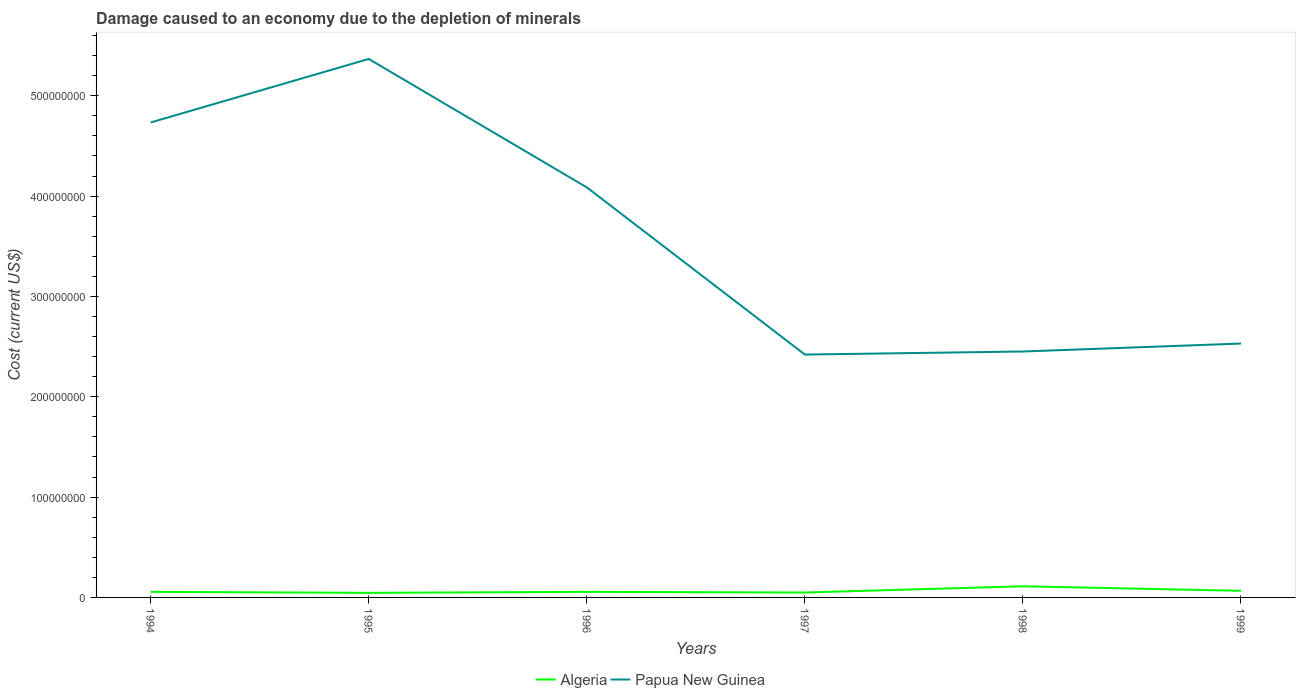Does the line corresponding to Papua New Guinea intersect with the line corresponding to Algeria?
Offer a terse response. No. Across all years, what is the maximum cost of damage caused due to the depletion of minerals in Algeria?
Offer a very short reply. 4.58e+06. In which year was the cost of damage caused due to the depletion of minerals in Algeria maximum?
Ensure brevity in your answer.  1995. What is the total cost of damage caused due to the depletion of minerals in Algeria in the graph?
Your response must be concise. -5.57e+06. What is the difference between the highest and the second highest cost of damage caused due to the depletion of minerals in Algeria?
Keep it short and to the point. 6.54e+06. Is the cost of damage caused due to the depletion of minerals in Algeria strictly greater than the cost of damage caused due to the depletion of minerals in Papua New Guinea over the years?
Give a very brief answer. Yes. How many years are there in the graph?
Your response must be concise. 6. Are the values on the major ticks of Y-axis written in scientific E-notation?
Make the answer very short. No. How are the legend labels stacked?
Keep it short and to the point. Horizontal. What is the title of the graph?
Ensure brevity in your answer.  Damage caused to an economy due to the depletion of minerals. What is the label or title of the X-axis?
Offer a very short reply. Years. What is the label or title of the Y-axis?
Give a very brief answer. Cost (current US$). What is the Cost (current US$) in Algeria in 1994?
Ensure brevity in your answer.  5.54e+06. What is the Cost (current US$) of Papua New Guinea in 1994?
Your response must be concise. 4.73e+08. What is the Cost (current US$) in Algeria in 1995?
Offer a terse response. 4.58e+06. What is the Cost (current US$) in Papua New Guinea in 1995?
Your response must be concise. 5.37e+08. What is the Cost (current US$) of Algeria in 1996?
Provide a succinct answer. 5.55e+06. What is the Cost (current US$) of Papua New Guinea in 1996?
Make the answer very short. 4.09e+08. What is the Cost (current US$) in Algeria in 1997?
Provide a succinct answer. 4.89e+06. What is the Cost (current US$) in Papua New Guinea in 1997?
Provide a short and direct response. 2.42e+08. What is the Cost (current US$) in Algeria in 1998?
Offer a very short reply. 1.11e+07. What is the Cost (current US$) in Papua New Guinea in 1998?
Your answer should be very brief. 2.45e+08. What is the Cost (current US$) of Algeria in 1999?
Ensure brevity in your answer.  6.60e+06. What is the Cost (current US$) in Papua New Guinea in 1999?
Offer a very short reply. 2.53e+08. Across all years, what is the maximum Cost (current US$) in Algeria?
Your answer should be very brief. 1.11e+07. Across all years, what is the maximum Cost (current US$) of Papua New Guinea?
Provide a succinct answer. 5.37e+08. Across all years, what is the minimum Cost (current US$) of Algeria?
Make the answer very short. 4.58e+06. Across all years, what is the minimum Cost (current US$) of Papua New Guinea?
Your response must be concise. 2.42e+08. What is the total Cost (current US$) of Algeria in the graph?
Your response must be concise. 3.83e+07. What is the total Cost (current US$) in Papua New Guinea in the graph?
Your response must be concise. 2.16e+09. What is the difference between the Cost (current US$) of Algeria in 1994 and that in 1995?
Offer a very short reply. 9.70e+05. What is the difference between the Cost (current US$) in Papua New Guinea in 1994 and that in 1995?
Give a very brief answer. -6.33e+07. What is the difference between the Cost (current US$) of Algeria in 1994 and that in 1996?
Offer a very short reply. -5232.42. What is the difference between the Cost (current US$) in Papua New Guinea in 1994 and that in 1996?
Provide a succinct answer. 6.47e+07. What is the difference between the Cost (current US$) in Algeria in 1994 and that in 1997?
Make the answer very short. 6.50e+05. What is the difference between the Cost (current US$) in Papua New Guinea in 1994 and that in 1997?
Ensure brevity in your answer.  2.31e+08. What is the difference between the Cost (current US$) of Algeria in 1994 and that in 1998?
Your response must be concise. -5.57e+06. What is the difference between the Cost (current US$) of Papua New Guinea in 1994 and that in 1998?
Provide a short and direct response. 2.28e+08. What is the difference between the Cost (current US$) in Algeria in 1994 and that in 1999?
Give a very brief answer. -1.06e+06. What is the difference between the Cost (current US$) in Papua New Guinea in 1994 and that in 1999?
Offer a very short reply. 2.20e+08. What is the difference between the Cost (current US$) of Algeria in 1995 and that in 1996?
Offer a very short reply. -9.75e+05. What is the difference between the Cost (current US$) in Papua New Guinea in 1995 and that in 1996?
Your response must be concise. 1.28e+08. What is the difference between the Cost (current US$) of Algeria in 1995 and that in 1997?
Make the answer very short. -3.20e+05. What is the difference between the Cost (current US$) in Papua New Guinea in 1995 and that in 1997?
Provide a succinct answer. 2.95e+08. What is the difference between the Cost (current US$) in Algeria in 1995 and that in 1998?
Give a very brief answer. -6.54e+06. What is the difference between the Cost (current US$) of Papua New Guinea in 1995 and that in 1998?
Offer a very short reply. 2.92e+08. What is the difference between the Cost (current US$) in Algeria in 1995 and that in 1999?
Your answer should be very brief. -2.03e+06. What is the difference between the Cost (current US$) in Papua New Guinea in 1995 and that in 1999?
Offer a very short reply. 2.84e+08. What is the difference between the Cost (current US$) in Algeria in 1996 and that in 1997?
Your response must be concise. 6.55e+05. What is the difference between the Cost (current US$) in Papua New Guinea in 1996 and that in 1997?
Ensure brevity in your answer.  1.67e+08. What is the difference between the Cost (current US$) of Algeria in 1996 and that in 1998?
Give a very brief answer. -5.56e+06. What is the difference between the Cost (current US$) of Papua New Guinea in 1996 and that in 1998?
Your answer should be very brief. 1.64e+08. What is the difference between the Cost (current US$) of Algeria in 1996 and that in 1999?
Keep it short and to the point. -1.05e+06. What is the difference between the Cost (current US$) in Papua New Guinea in 1996 and that in 1999?
Ensure brevity in your answer.  1.56e+08. What is the difference between the Cost (current US$) of Algeria in 1997 and that in 1998?
Keep it short and to the point. -6.22e+06. What is the difference between the Cost (current US$) in Papua New Guinea in 1997 and that in 1998?
Ensure brevity in your answer.  -3.05e+06. What is the difference between the Cost (current US$) in Algeria in 1997 and that in 1999?
Offer a very short reply. -1.71e+06. What is the difference between the Cost (current US$) in Papua New Guinea in 1997 and that in 1999?
Provide a succinct answer. -1.10e+07. What is the difference between the Cost (current US$) in Algeria in 1998 and that in 1999?
Provide a short and direct response. 4.51e+06. What is the difference between the Cost (current US$) in Papua New Guinea in 1998 and that in 1999?
Give a very brief answer. -7.93e+06. What is the difference between the Cost (current US$) in Algeria in 1994 and the Cost (current US$) in Papua New Guinea in 1995?
Give a very brief answer. -5.31e+08. What is the difference between the Cost (current US$) of Algeria in 1994 and the Cost (current US$) of Papua New Guinea in 1996?
Your answer should be very brief. -4.03e+08. What is the difference between the Cost (current US$) of Algeria in 1994 and the Cost (current US$) of Papua New Guinea in 1997?
Give a very brief answer. -2.37e+08. What is the difference between the Cost (current US$) of Algeria in 1994 and the Cost (current US$) of Papua New Guinea in 1998?
Keep it short and to the point. -2.40e+08. What is the difference between the Cost (current US$) in Algeria in 1994 and the Cost (current US$) in Papua New Guinea in 1999?
Ensure brevity in your answer.  -2.47e+08. What is the difference between the Cost (current US$) of Algeria in 1995 and the Cost (current US$) of Papua New Guinea in 1996?
Keep it short and to the point. -4.04e+08. What is the difference between the Cost (current US$) in Algeria in 1995 and the Cost (current US$) in Papua New Guinea in 1997?
Make the answer very short. -2.37e+08. What is the difference between the Cost (current US$) in Algeria in 1995 and the Cost (current US$) in Papua New Guinea in 1998?
Ensure brevity in your answer.  -2.41e+08. What is the difference between the Cost (current US$) of Algeria in 1995 and the Cost (current US$) of Papua New Guinea in 1999?
Your answer should be compact. -2.48e+08. What is the difference between the Cost (current US$) of Algeria in 1996 and the Cost (current US$) of Papua New Guinea in 1997?
Offer a very short reply. -2.37e+08. What is the difference between the Cost (current US$) in Algeria in 1996 and the Cost (current US$) in Papua New Guinea in 1998?
Your response must be concise. -2.40e+08. What is the difference between the Cost (current US$) in Algeria in 1996 and the Cost (current US$) in Papua New Guinea in 1999?
Ensure brevity in your answer.  -2.47e+08. What is the difference between the Cost (current US$) of Algeria in 1997 and the Cost (current US$) of Papua New Guinea in 1998?
Your answer should be very brief. -2.40e+08. What is the difference between the Cost (current US$) in Algeria in 1997 and the Cost (current US$) in Papua New Guinea in 1999?
Give a very brief answer. -2.48e+08. What is the difference between the Cost (current US$) in Algeria in 1998 and the Cost (current US$) in Papua New Guinea in 1999?
Your response must be concise. -2.42e+08. What is the average Cost (current US$) in Algeria per year?
Your answer should be very brief. 6.38e+06. What is the average Cost (current US$) of Papua New Guinea per year?
Make the answer very short. 3.60e+08. In the year 1994, what is the difference between the Cost (current US$) in Algeria and Cost (current US$) in Papua New Guinea?
Ensure brevity in your answer.  -4.68e+08. In the year 1995, what is the difference between the Cost (current US$) in Algeria and Cost (current US$) in Papua New Guinea?
Provide a succinct answer. -5.32e+08. In the year 1996, what is the difference between the Cost (current US$) of Algeria and Cost (current US$) of Papua New Guinea?
Provide a succinct answer. -4.03e+08. In the year 1997, what is the difference between the Cost (current US$) in Algeria and Cost (current US$) in Papua New Guinea?
Keep it short and to the point. -2.37e+08. In the year 1998, what is the difference between the Cost (current US$) of Algeria and Cost (current US$) of Papua New Guinea?
Offer a very short reply. -2.34e+08. In the year 1999, what is the difference between the Cost (current US$) of Algeria and Cost (current US$) of Papua New Guinea?
Keep it short and to the point. -2.46e+08. What is the ratio of the Cost (current US$) in Algeria in 1994 to that in 1995?
Your answer should be compact. 1.21. What is the ratio of the Cost (current US$) of Papua New Guinea in 1994 to that in 1995?
Offer a very short reply. 0.88. What is the ratio of the Cost (current US$) in Papua New Guinea in 1994 to that in 1996?
Ensure brevity in your answer.  1.16. What is the ratio of the Cost (current US$) in Algeria in 1994 to that in 1997?
Give a very brief answer. 1.13. What is the ratio of the Cost (current US$) in Papua New Guinea in 1994 to that in 1997?
Your answer should be compact. 1.96. What is the ratio of the Cost (current US$) of Algeria in 1994 to that in 1998?
Ensure brevity in your answer.  0.5. What is the ratio of the Cost (current US$) in Papua New Guinea in 1994 to that in 1998?
Ensure brevity in your answer.  1.93. What is the ratio of the Cost (current US$) of Algeria in 1994 to that in 1999?
Offer a very short reply. 0.84. What is the ratio of the Cost (current US$) in Papua New Guinea in 1994 to that in 1999?
Offer a very short reply. 1.87. What is the ratio of the Cost (current US$) in Algeria in 1995 to that in 1996?
Your response must be concise. 0.82. What is the ratio of the Cost (current US$) in Papua New Guinea in 1995 to that in 1996?
Provide a short and direct response. 1.31. What is the ratio of the Cost (current US$) of Algeria in 1995 to that in 1997?
Give a very brief answer. 0.93. What is the ratio of the Cost (current US$) in Papua New Guinea in 1995 to that in 1997?
Your response must be concise. 2.22. What is the ratio of the Cost (current US$) in Algeria in 1995 to that in 1998?
Keep it short and to the point. 0.41. What is the ratio of the Cost (current US$) of Papua New Guinea in 1995 to that in 1998?
Your answer should be very brief. 2.19. What is the ratio of the Cost (current US$) of Algeria in 1995 to that in 1999?
Keep it short and to the point. 0.69. What is the ratio of the Cost (current US$) in Papua New Guinea in 1995 to that in 1999?
Provide a short and direct response. 2.12. What is the ratio of the Cost (current US$) in Algeria in 1996 to that in 1997?
Offer a very short reply. 1.13. What is the ratio of the Cost (current US$) of Papua New Guinea in 1996 to that in 1997?
Provide a short and direct response. 1.69. What is the ratio of the Cost (current US$) of Algeria in 1996 to that in 1998?
Keep it short and to the point. 0.5. What is the ratio of the Cost (current US$) of Papua New Guinea in 1996 to that in 1998?
Ensure brevity in your answer.  1.67. What is the ratio of the Cost (current US$) of Algeria in 1996 to that in 1999?
Make the answer very short. 0.84. What is the ratio of the Cost (current US$) of Papua New Guinea in 1996 to that in 1999?
Make the answer very short. 1.62. What is the ratio of the Cost (current US$) of Algeria in 1997 to that in 1998?
Provide a succinct answer. 0.44. What is the ratio of the Cost (current US$) in Papua New Guinea in 1997 to that in 1998?
Give a very brief answer. 0.99. What is the ratio of the Cost (current US$) in Algeria in 1997 to that in 1999?
Keep it short and to the point. 0.74. What is the ratio of the Cost (current US$) of Papua New Guinea in 1997 to that in 1999?
Provide a succinct answer. 0.96. What is the ratio of the Cost (current US$) in Algeria in 1998 to that in 1999?
Give a very brief answer. 1.68. What is the ratio of the Cost (current US$) in Papua New Guinea in 1998 to that in 1999?
Keep it short and to the point. 0.97. What is the difference between the highest and the second highest Cost (current US$) in Algeria?
Provide a short and direct response. 4.51e+06. What is the difference between the highest and the second highest Cost (current US$) in Papua New Guinea?
Your response must be concise. 6.33e+07. What is the difference between the highest and the lowest Cost (current US$) of Algeria?
Offer a terse response. 6.54e+06. What is the difference between the highest and the lowest Cost (current US$) in Papua New Guinea?
Your response must be concise. 2.95e+08. 